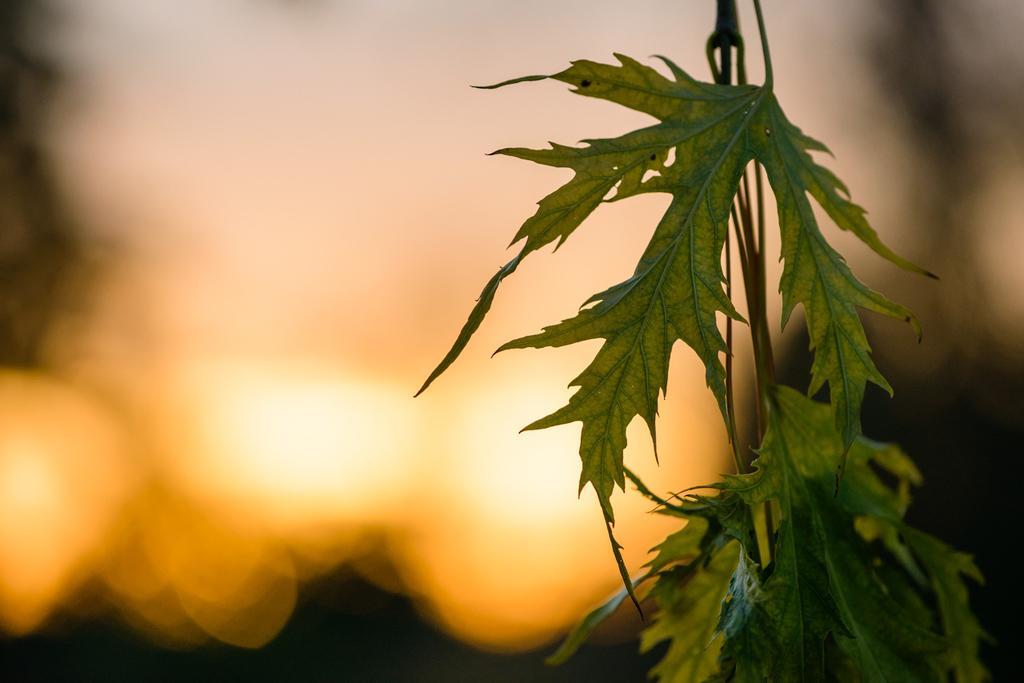Could you give a brief overview of what you see in this image? In the picture I can see a plant. The background of the image is blurred. 